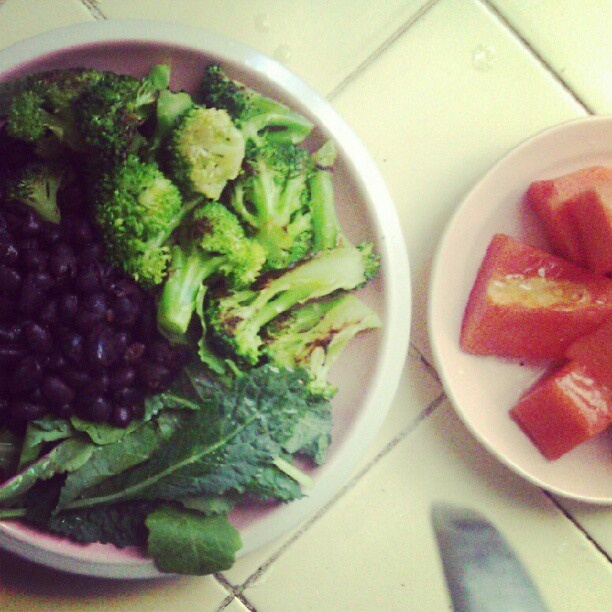Describe the objects in this image and their specific colors. I can see bowl in tan, black, gray, darkgreen, and green tones, broccoli in tan, black, olive, darkgreen, and lightgreen tones, and knife in tan, darkgray, and gray tones in this image. 